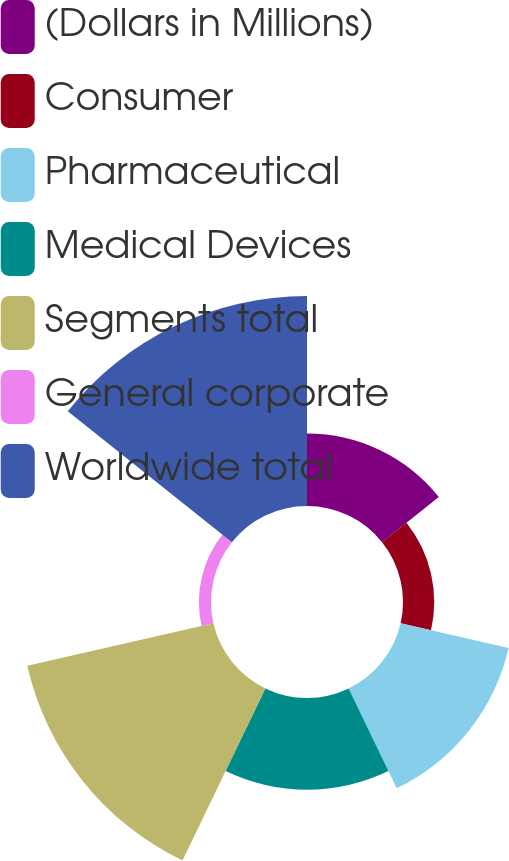Convert chart to OTSL. <chart><loc_0><loc_0><loc_500><loc_500><pie_chart><fcel>(Dollars in Millions)<fcel>Consumer<fcel>Pharmaceutical<fcel>Medical Devices<fcel>Segments total<fcel>General corporate<fcel>Worldwide total<nl><fcel>10.09%<fcel>4.34%<fcel>15.4%<fcel>12.75%<fcel>26.55%<fcel>1.68%<fcel>29.2%<nl></chart> 